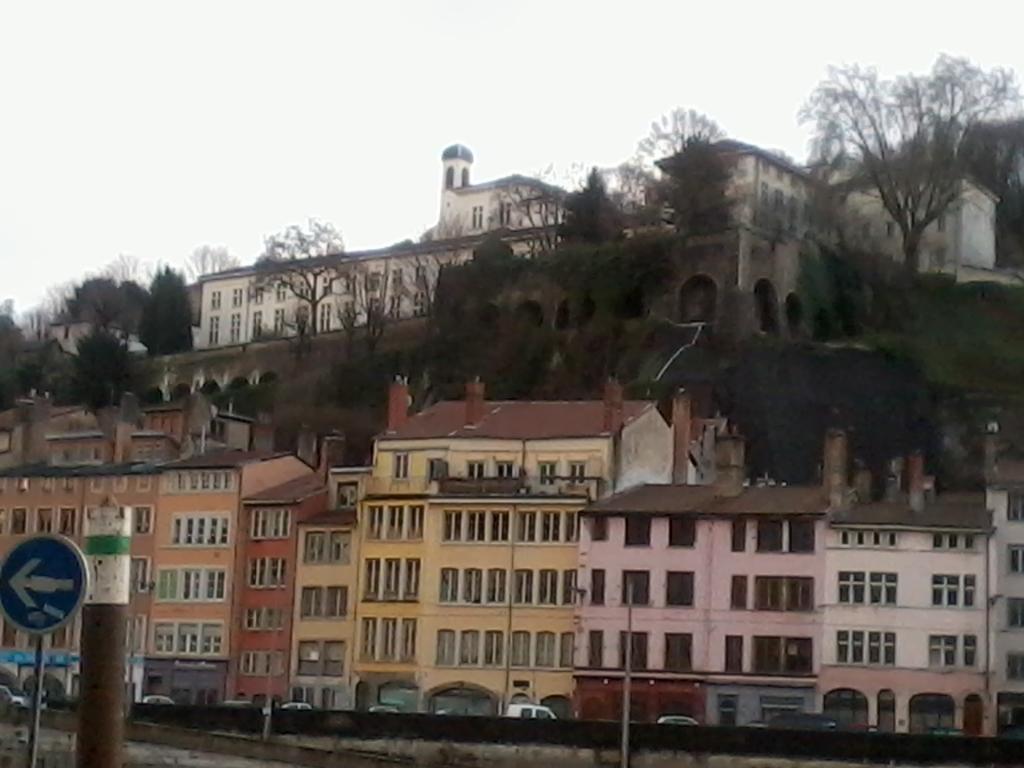In one or two sentences, can you explain what this image depicts? In this image there are buildings, trees and there is a pole in the front and there is a sign board. On the left side in the center there are vehicles and the sky is cloudy. 